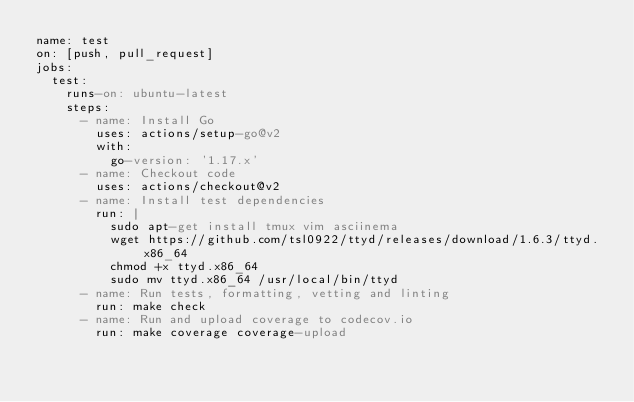Convert code to text. <code><loc_0><loc_0><loc_500><loc_500><_YAML_>name: test
on: [push, pull_request]
jobs:
  test:
    runs-on: ubuntu-latest
    steps:
      - name: Install Go
        uses: actions/setup-go@v2
        with:
          go-version: '1.17.x'
      - name: Checkout code
        uses: actions/checkout@v2
      - name: Install test dependencies
        run: |
          sudo apt-get install tmux vim asciinema
          wget https://github.com/tsl0922/ttyd/releases/download/1.6.3/ttyd.x86_64
          chmod +x ttyd.x86_64
          sudo mv ttyd.x86_64 /usr/local/bin/ttyd
      - name: Run tests, formatting, vetting and linting
        run: make check
      - name: Run and upload coverage to codecov.io
        run: make coverage coverage-upload
</code> 